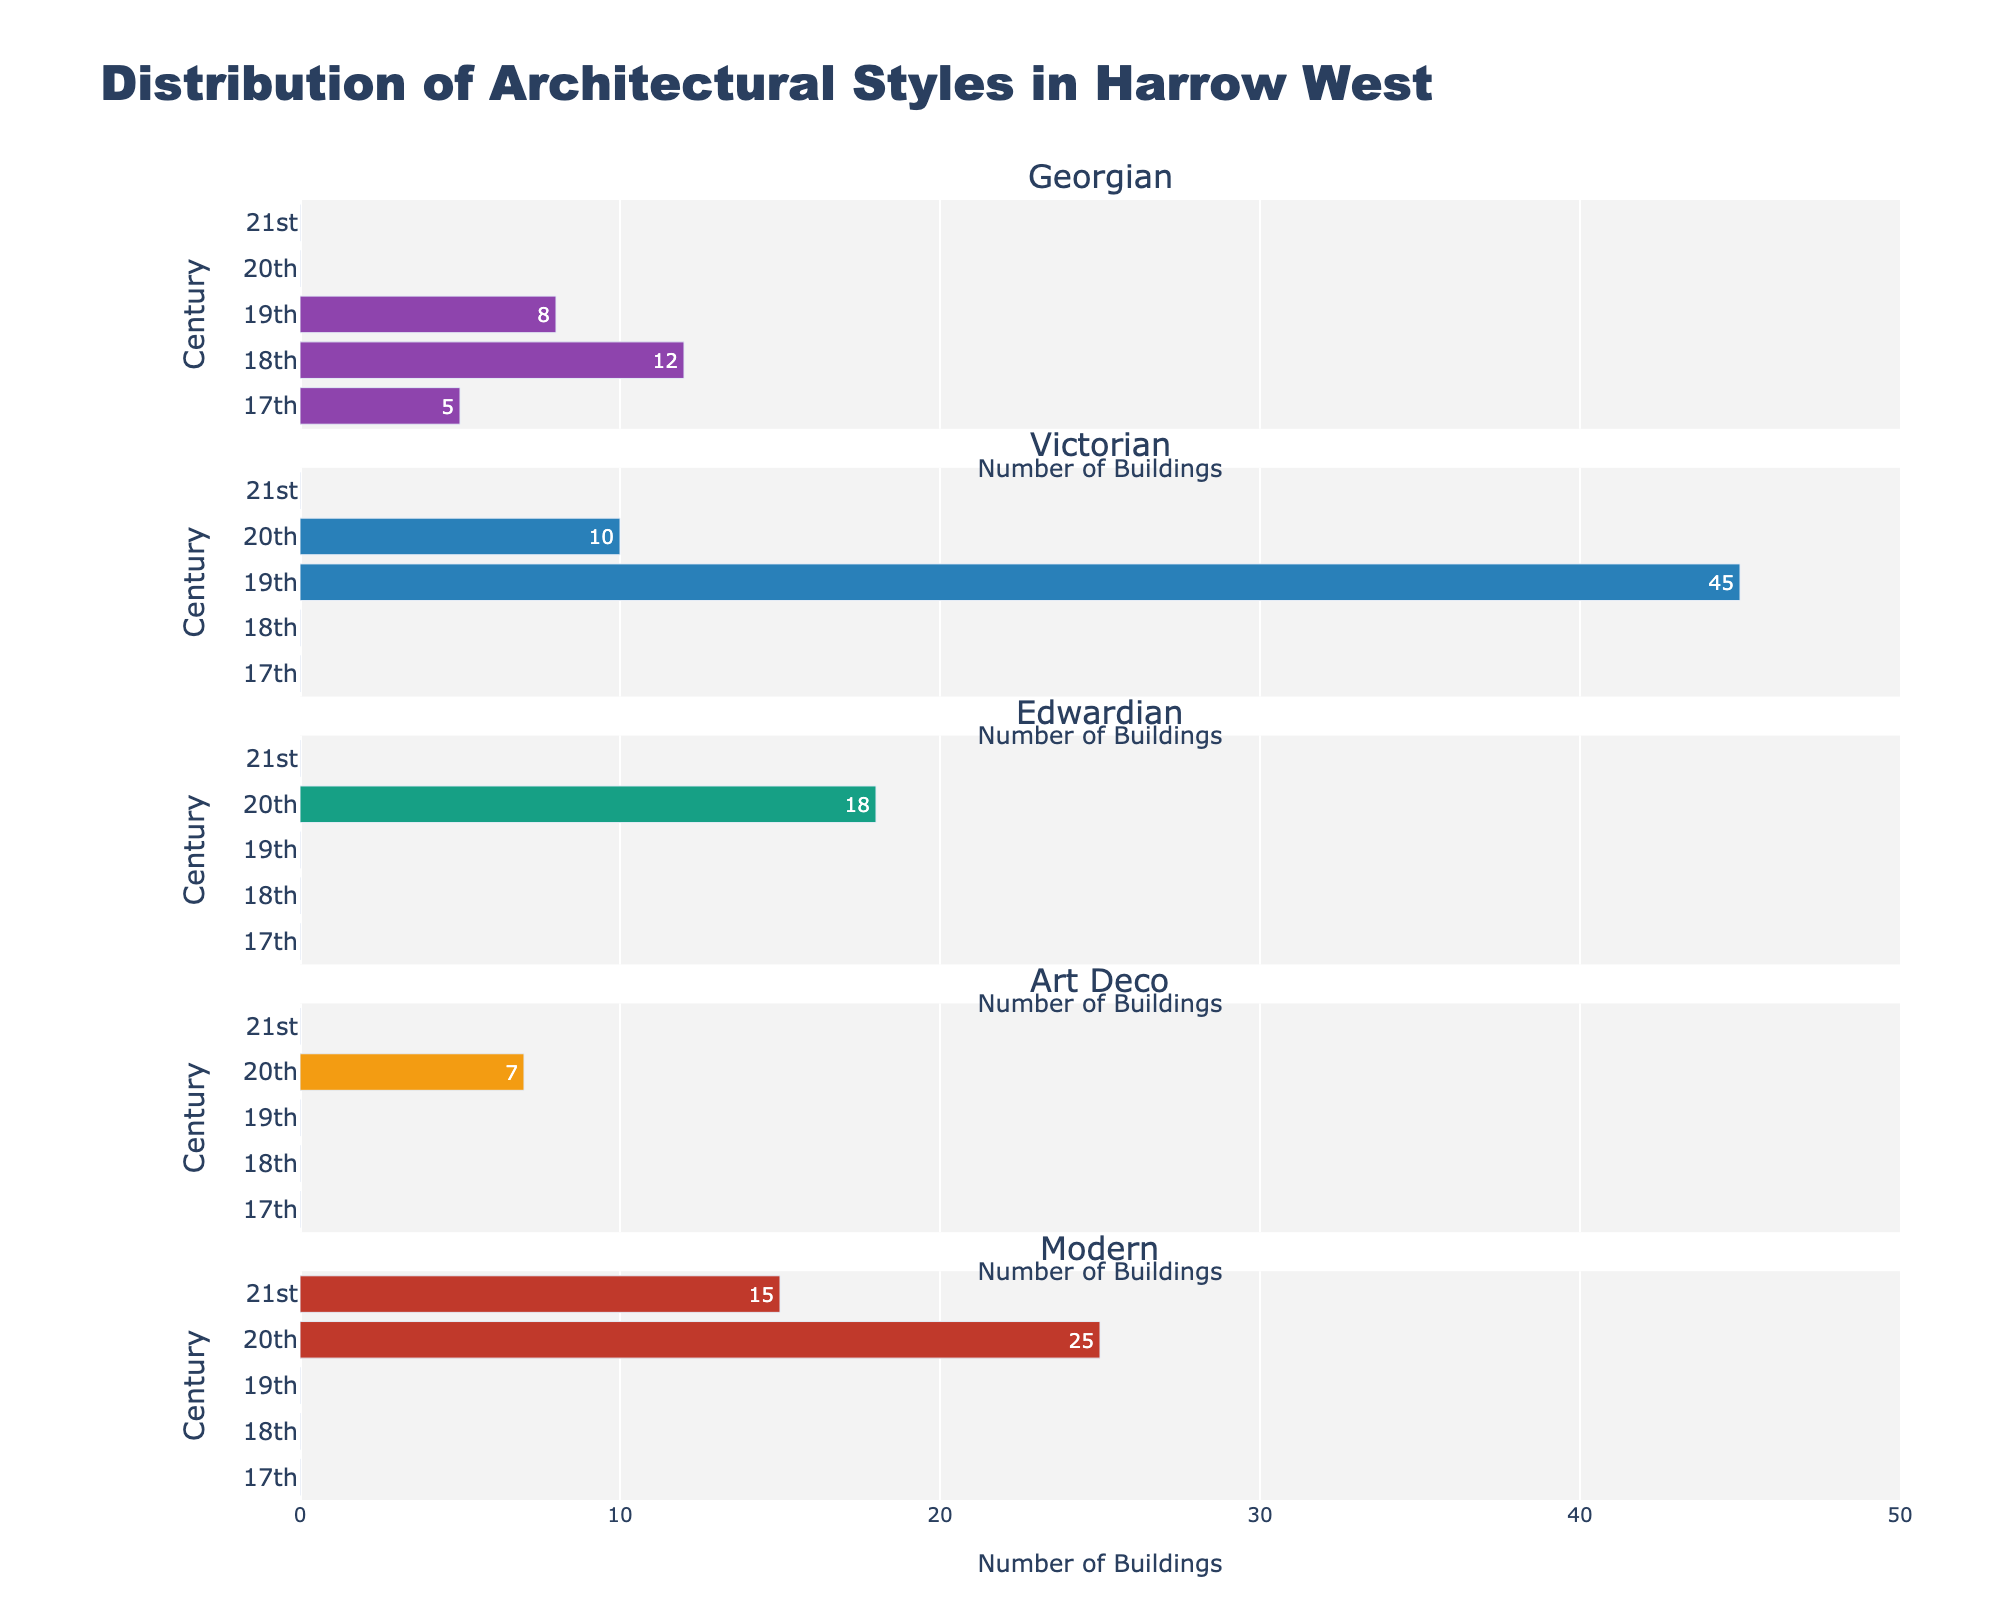What is the title of the figure? The title is prominently displayed at the top of the figure.
Answer: Distribution of Architectural Styles in Harrow West Which century has the most Victorian-style buildings? By looking at the sub-plot titled 'Victorian', identify which century has the highest bar.
Answer: 19th century How many Art Deco buildings were constructed in the 20th century? Locate the 'Art Deco' subplot, find the bar corresponding to the 20th century, and read the value indicated inside the bar.
Answer: 7 Compare the number of Georgian buildings in the 17th and 18th centuries. Which century has more? Look at the 'Georgian' subplot and compare the bar lengths for the 17th and 18th centuries.
Answer: 18th century How many total buildings of all styles were constructed in the 21st century? Add the values of all the styles (Georgian, Victorian, Edwardian, Art Deco, Modern) for the 21st century. Since only Modern buildings are present, it's 15.
Answer: 15 Which architectural style is absent in the 18th century? Check each subplot (Georgian, Victorian, Edwardian, Art Deco, Modern) for bars pertaining to the 18th century. Only Georgian style has a non-zero value in the 18th century.
Answer: Victorian, Edwardian, Art Deco, Modern In which century were the most Modern buildings constructed? Examine the 'Modern' subplot and find which century has the tallest bar.
Answer: 20th century What is the difference between the number of Georgian buildings in the 18th and 19th centuries? Subtract the number of Georgian buildings in the 19th century from those in the 18th century (12 in 18th century - 8 in 19th century).
Answer: 4 Which architectural style saw construction in all centuries from the 17th to the 21st? By looking at each subplot, determine which style has data in every century listed on the y-axis. None of the styles are present in all centuries.
Answer: None 